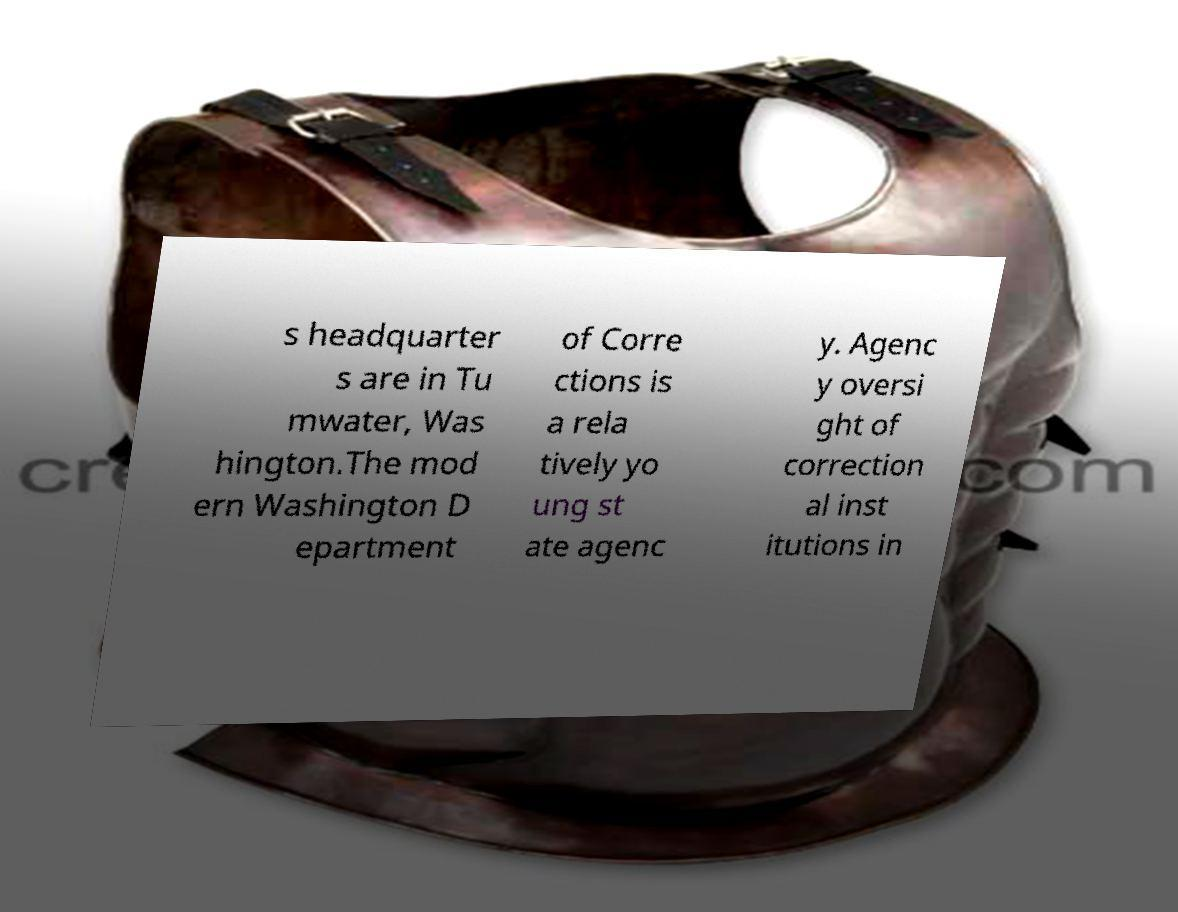There's text embedded in this image that I need extracted. Can you transcribe it verbatim? s headquarter s are in Tu mwater, Was hington.The mod ern Washington D epartment of Corre ctions is a rela tively yo ung st ate agenc y. Agenc y oversi ght of correction al inst itutions in 